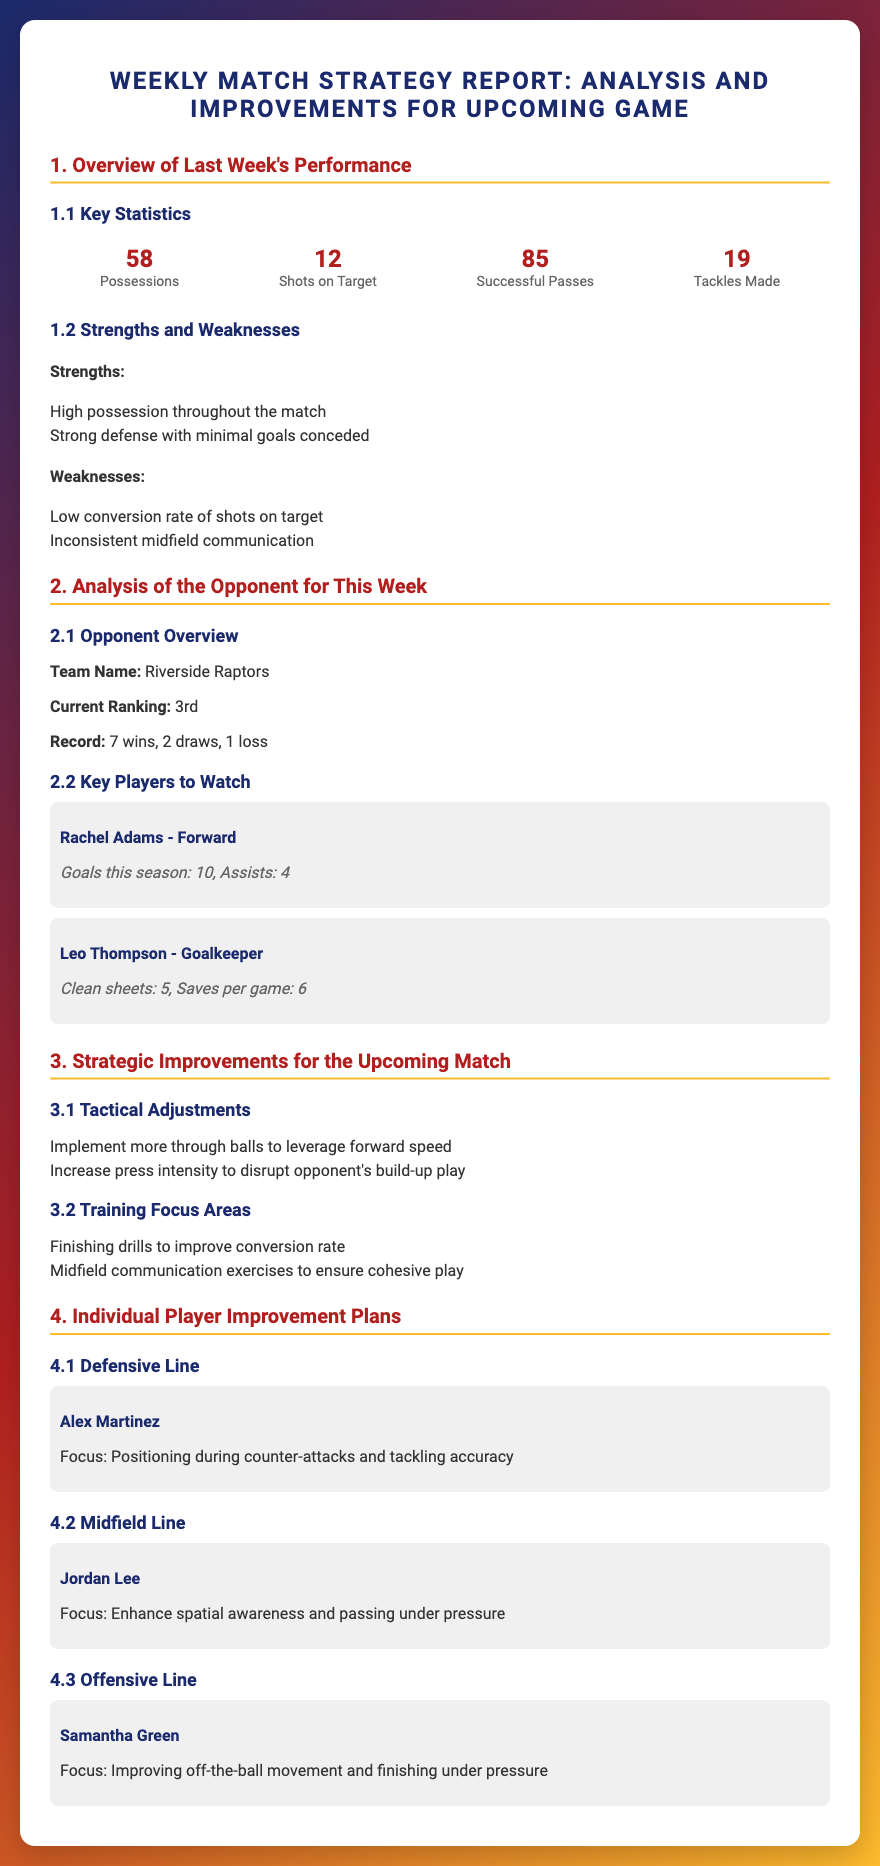What is the total number of possessions? The total number of possessions is directly stated in the key statistics section of the report.
Answer: 58 What is the name of the opponent team? The opponent team name is provided in the analysis section of the report.
Answer: Riverside Raptors How many goals has Rachel Adams scored this season? The number of goals scored by Rachel Adams can be found in the key players section of the report.
Answer: 10 What is the focus for Alex Martinez's improvement? The focus for Alex Martinez's improvement is specifically outlined in the individual player improvement plans.
Answer: Positioning during counter-attacks What is a highlighted weakness from last week's performance? Weaknesses listed in the report include issues that need to be improved upon for future matches.
Answer: Low conversion rate of shots on target What tactical adjustment is suggested for the upcoming match? The tactical adjustments recommended for the match are mentioned in the strategic improvements section.
Answer: Implement more through balls How many tackles were made in the last match? This number can be found in the key statistics which provide various performance metrics.
Answer: 19 What is the clean sheets statistic for Leo Thompson? The clean sheets statistic for Leo Thompson is stated in the key players section.
Answer: 5 What should be the focus area for Jordan Lee's training? The focus area for Jordan Lee is specifically mentioned in their individual improvement plan.
Answer: Enhance spatial awareness 